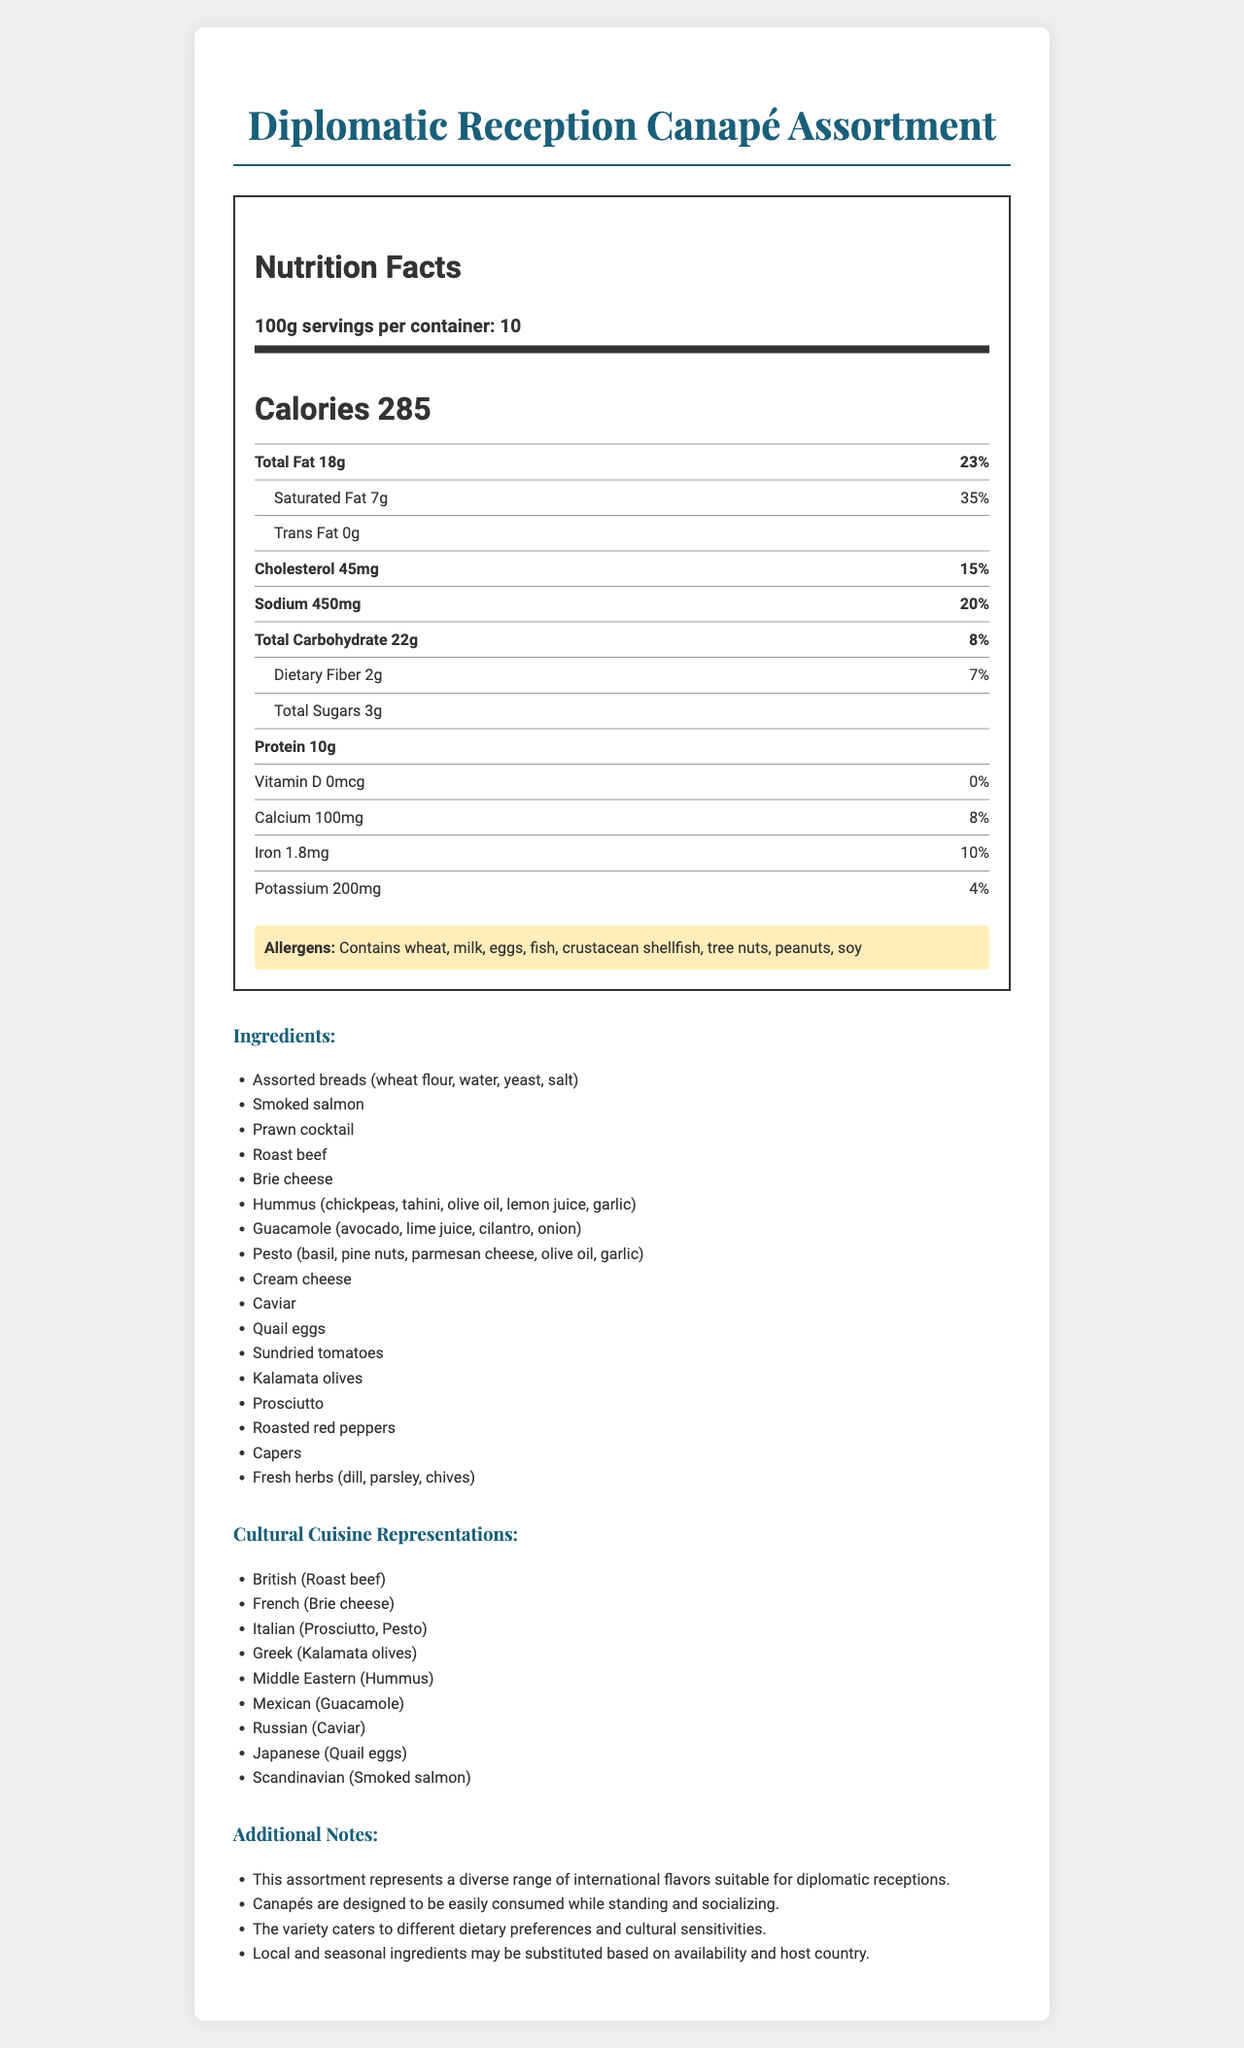what is the product name? The product name is stated clearly at the beginning of the document.
Answer: Diplomatic Reception Canapé Assortment what is the serving size? The serving size is stated as 100g in the nutrition facts section.
Answer: 100g how many servings per container are there? The document specifies that there are 10 servings per container.
Answer: 10 how many calories are in one serving? The document states that there are 285 calories per serving.
Answer: 285 what is the total fat content per serving? The total fat content per serving is found in the detailed nutrition facts.
Answer: 18g which country’s cuisine is represented by Prosciutto in the canapé assortment? The cultural cuisine representations list Prosciutto under Italian cuisine.
Answer: Italian which of the following is NOT listed as an allergen? A. Soy B. Milk C. Gluten D. Fish The allergens listed in the document are wheat, milk, eggs, fish, crustacean shellfish, tree nuts, peanuts, and soy. Gluten is not specifically listed.
Answer: C. Gluten which term refers to the flavor representation of quail eggs? A. Russian B. Japanese C. Mexican D. Greek The cultural cuisine representations list quail eggs under Japanese cuisine.
Answer: B. Japanese does the canapé assortment contain trans fat? The document clearly states that the trans fat content is 0g.
Answer: No is the assortment designed to accommodate various dietary preferences? The additional notes mention that the variety caters to different dietary preferences.
Answer: Yes summarize the main idea of the document. The document details the nutritional information, ingredients, cultural representations, and suitability for diplomatic receptions. It serves as a comprehensive guide to the canapé assortment's nutritional value and cultural diversity.
Answer: The document is a nutrition facts label for a Diplomatic Reception Canapé Assortment, highlighting its serving size, nutritional content, allergens, ingredients, and cultural cuisine representations. It emphasizes the diversity of flavors and the assortment's suitability for diplomatic events. what is the percentage of daily value for dietary fiber per serving? The dietary fiber daily value percentage is listed as 7% in the nutrition facts section.
Answer: 7% how much sodium is in one serving? The document lists the sodium content per serving as 450mg.
Answer: 450mg what is the purpose of the 'additional notes' section in the document? The additional notes section explains the assortment's appropriateness for events, variety in flavors, and potential ingredient adjustments.
Answer: To provide context and extra information about the canapé assortment's suitability for diplomatic receptions, versatility, and ingredient substitutions. can local and seasonal ingredients be used in this canapé assortment? The additional notes mention that local and seasonal ingredients may be substituted based on availability and the host country.
Answer: Yes how much Vitamin D is in the canapé assortment? The nutrition facts state that the Vitamin D content per serving is 0mcg.
Answer: 0mcg what is the total carbohydrate content per serving? The document lists the total carbohydrate content per serving as 22g.
Answer: 22g which ingredients are used in the hummus for the canapés? A. Chickpeas, tahini, olive oil B. Chickpeas, lime juice, cilantro C. Chickpeas, pine nuts, basil The ingredients for the hummus listed are chickpeas, tahini, olive oil, lemon juice, and garlic.
Answer: A. Chickpeas, tahini, olive oil does the canapé assortment include caviar? The ingredient list includes caviar as one of the components of the assortment.
Answer: Yes how many grams of saturated fat are in one serving? The nutrition facts state that there are 7g of saturated fat per serving.
Answer: 7g is the canapé assortment described as suitable for standing and socializing? The additional notes state that the canapé assortment is designed to be easily consumed while standing and socializing.
Answer: Yes what is the total protein content per serving? The nutrition facts section lists the protein content as 10g per serving.
Answer: 10g which ingredient is not part of the canapé assortment? The ingredients section mentions sundried tomatoes but not fresh tomatoes specifically. So, assuming the differentiation, fresh tomatoes are not listed.
Answer: Tomatoes what is the main idea conveyed in the cultural cuisine representations section? The cultural cuisine representations section lists the different countries' cuisines that the assorted ingredients reflect, showcasing the international diversity of the canapés.
Answer: The section highlights the diverse international cuisines represented by the various ingredients in the canapé assortment. 